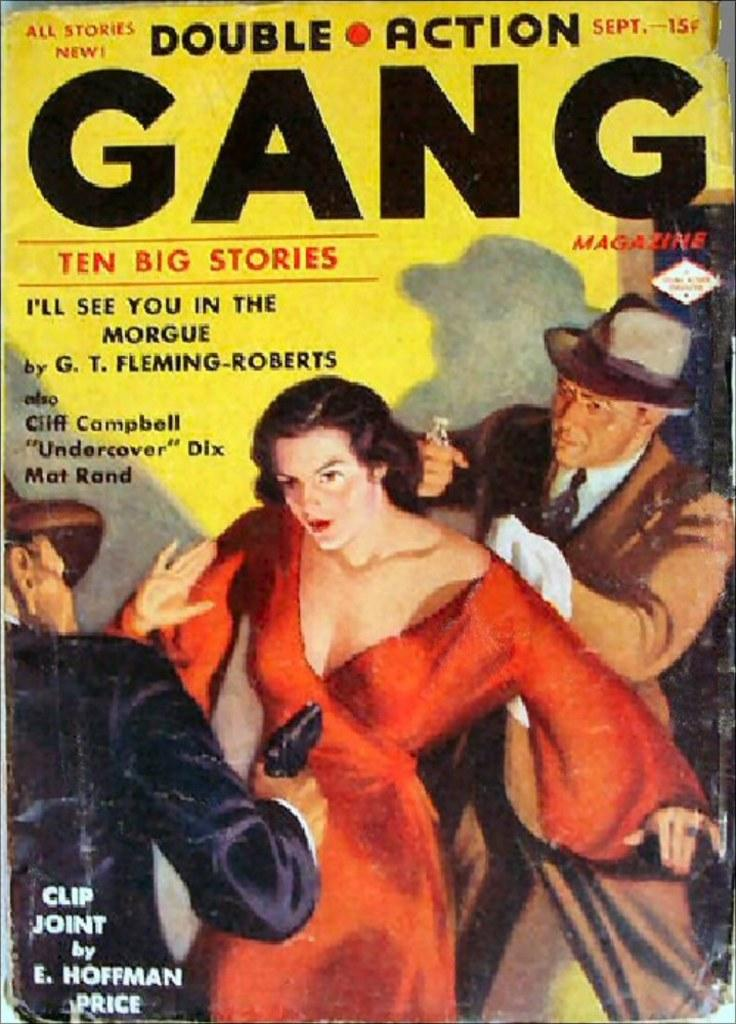What is the main object in the image? There is a book in the image. What type of content is in the book? The book contains images of men and women. Is there any text on the book? Yes, there is text on the book. How many birds are sitting on the notebook in the image? There is no notebook or birds present in the image. 